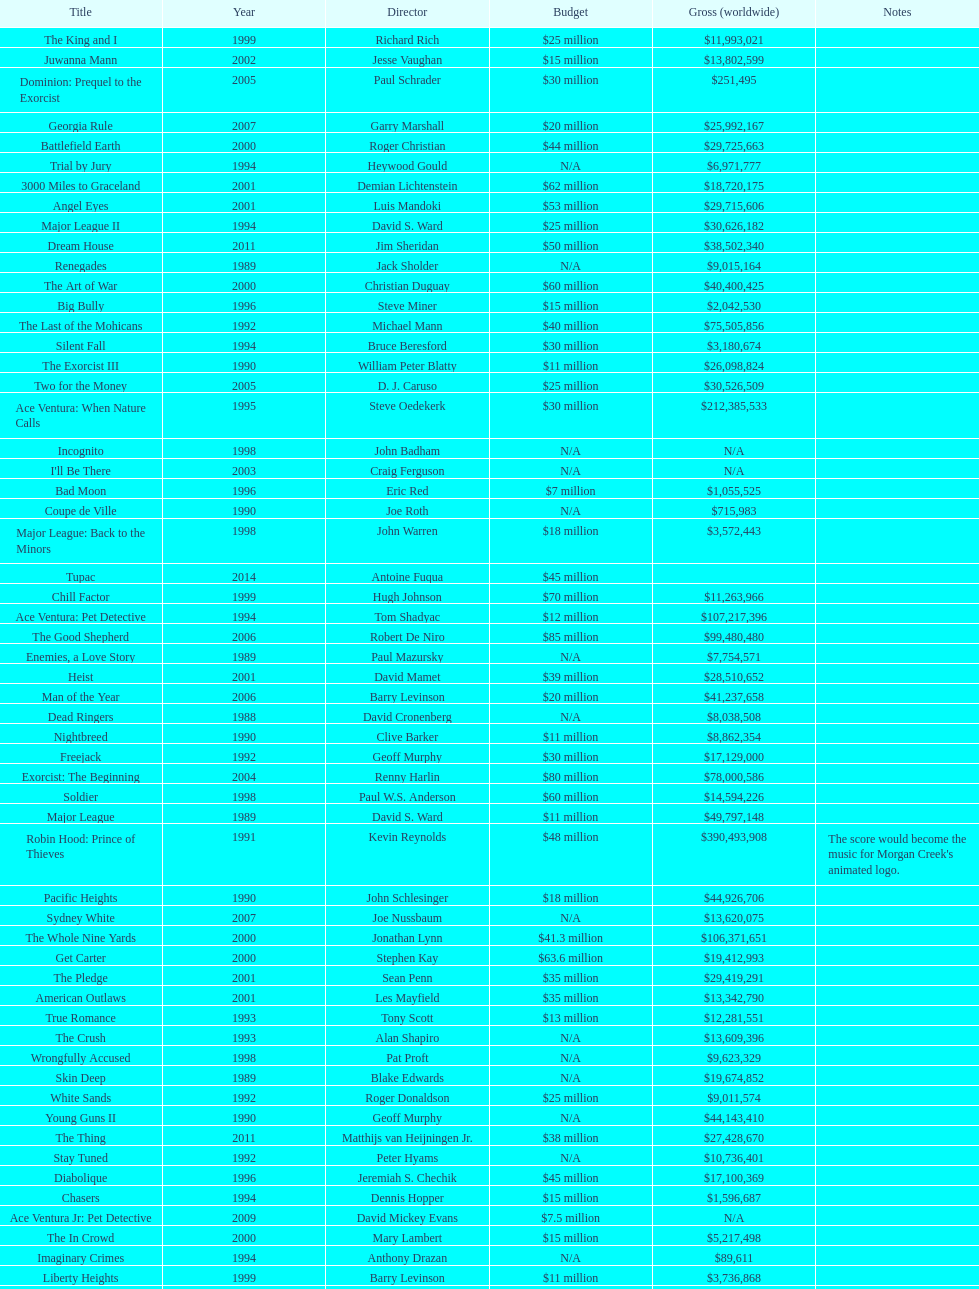Was the budget for young guns more or less than freejack's budget? Less. 